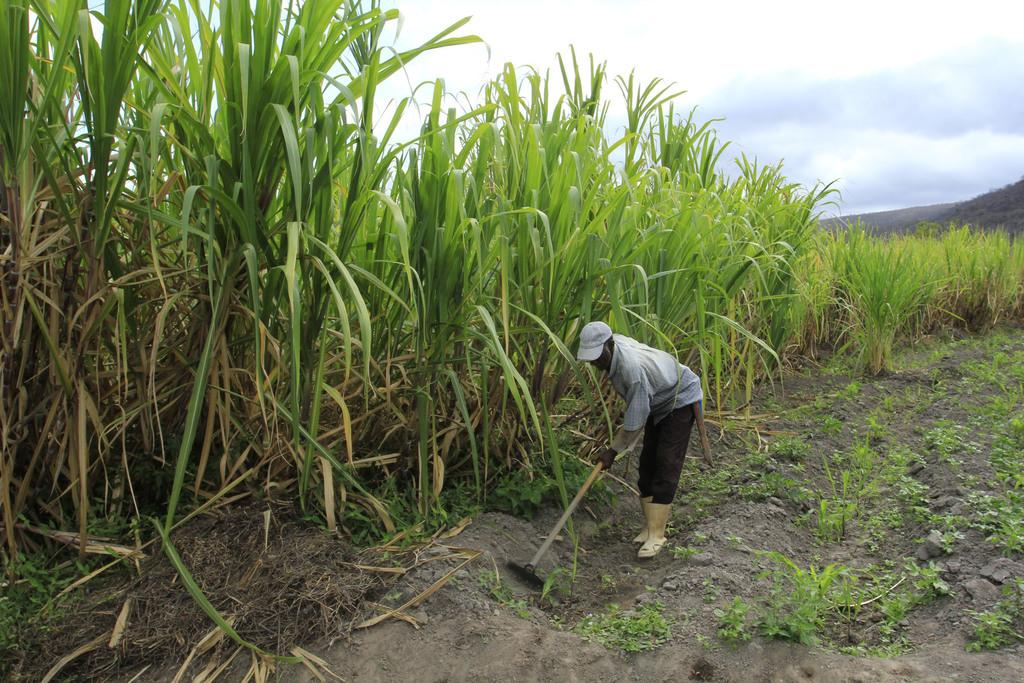What is happening in the image? There is a person in the image who is digging the field with an object. What can be seen beside the person? There are grass weeds beside the person. What is visible in the background of the image? The sky is visible in the background of the image. What word is causing the person to feel angry in the image? There is no indication of anger or any specific word in the image; the person is simply digging the field with an object. How many boats are visible in the image? There are no boats present in the image. 